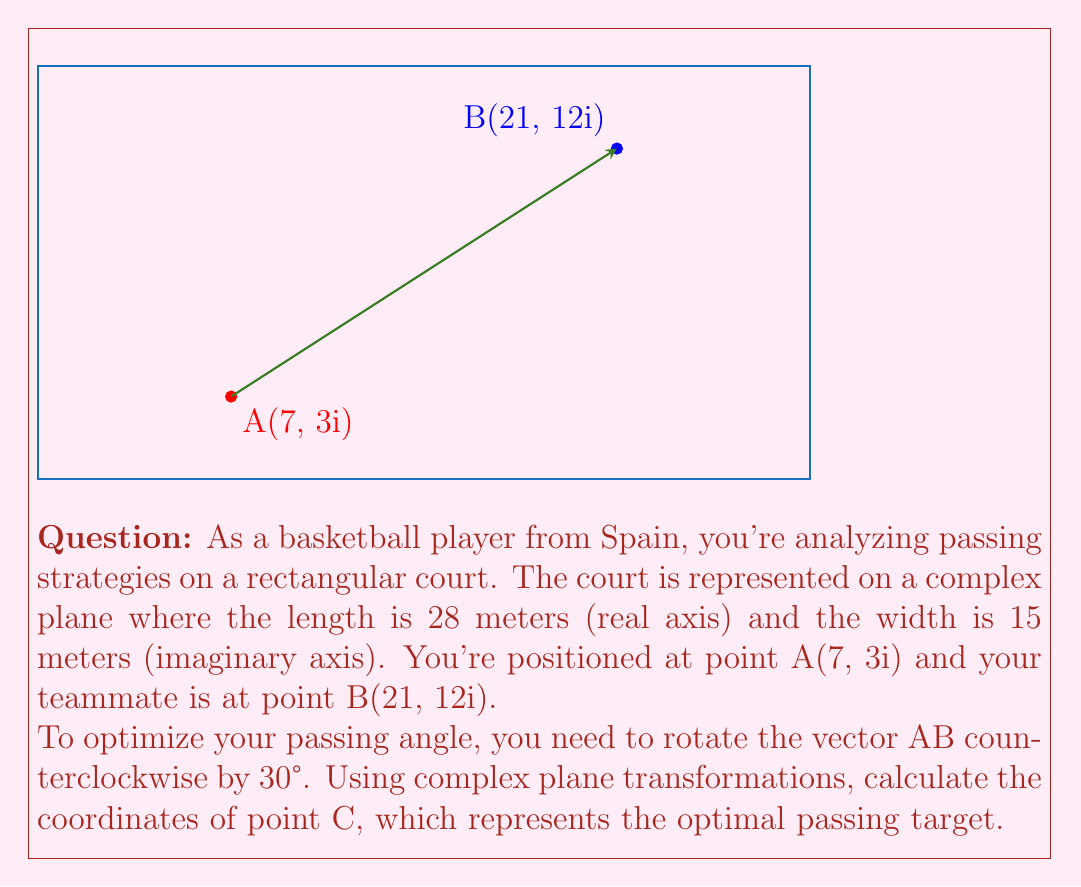Provide a solution to this math problem. Let's approach this step-by-step:

1) First, we need to represent points A and B as complex numbers:
   A = 7 + 3i
   B = 21 + 12i

2) The vector AB is represented by the complex number:
   $\vec{AB} = B - A = (21 + 12i) - (7 + 3i) = 14 + 9i$

3) To rotate a complex number by an angle θ, we multiply it by $e^{iθ}$. In this case, θ = 30° = π/6 radians.

4) The rotation formula is:
   $\vec{AC} = \vec{AB} \cdot e^{iπ/6}$

5) We know that $e^{iπ/6} = \cos(π/6) + i\sin(π/6) = \frac{\sqrt{3}}{2} + \frac{1}{2}i$

6) Now, let's multiply:
   $\vec{AC} = (14 + 9i)(\frac{\sqrt{3}}{2} + \frac{1}{2}i)$
   $= (14 \cdot \frac{\sqrt{3}}{2} - 9 \cdot \frac{1}{2}) + (14 \cdot \frac{1}{2} + 9 \cdot \frac{\sqrt{3}}{2})i$
   $= (7\sqrt{3} - \frac{9}{2}) + (7 + \frac{9\sqrt{3}}{2})i$

7) To find point C, we add this vector to the coordinates of point A:
   $C = A + \vec{AC} = (7 + 3i) + ((7\sqrt{3} - \frac{9}{2}) + (7 + \frac{9\sqrt{3}}{2})i)$
   $= (7 + 7\sqrt{3} - \frac{9}{2}) + (3 + 7 + \frac{9\sqrt{3}}{2})i$
   $= (7\sqrt{3} + \frac{5}{2}) + (10 + \frac{9\sqrt{3}}{2})i$

Therefore, the coordinates of point C are $(7\sqrt{3} + \frac{5}{2}, 10 + \frac{9\sqrt{3}}{2}i)$.
Answer: $(7\sqrt{3} + \frac{5}{2}, 10 + \frac{9\sqrt{3}}{2}i)$ 